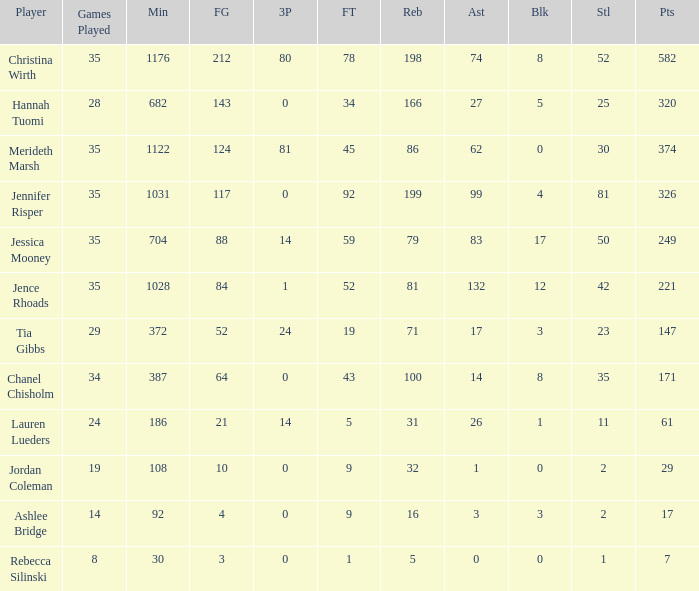Would you mind parsing the complete table? {'header': ['Player', 'Games Played', 'Min', 'FG', '3P', 'FT', 'Reb', 'Ast', 'Blk', 'Stl', 'Pts'], 'rows': [['Christina Wirth', '35', '1176', '212', '80', '78', '198', '74', '8', '52', '582'], ['Hannah Tuomi', '28', '682', '143', '0', '34', '166', '27', '5', '25', '320'], ['Merideth Marsh', '35', '1122', '124', '81', '45', '86', '62', '0', '30', '374'], ['Jennifer Risper', '35', '1031', '117', '0', '92', '199', '99', '4', '81', '326'], ['Jessica Mooney', '35', '704', '88', '14', '59', '79', '83', '17', '50', '249'], ['Jence Rhoads', '35', '1028', '84', '1', '52', '81', '132', '12', '42', '221'], ['Tia Gibbs', '29', '372', '52', '24', '19', '71', '17', '3', '23', '147'], ['Chanel Chisholm', '34', '387', '64', '0', '43', '100', '14', '8', '35', '171'], ['Lauren Lueders', '24', '186', '21', '14', '5', '31', '26', '1', '11', '61'], ['Jordan Coleman', '19', '108', '10', '0', '9', '32', '1', '0', '2', '29'], ['Ashlee Bridge', '14', '92', '4', '0', '9', '16', '3', '3', '2', '17'], ['Rebecca Silinski', '8', '30', '3', '0', '1', '5', '0', '0', '1', '7']]} For how long did Jordan Coleman play? 108.0. 